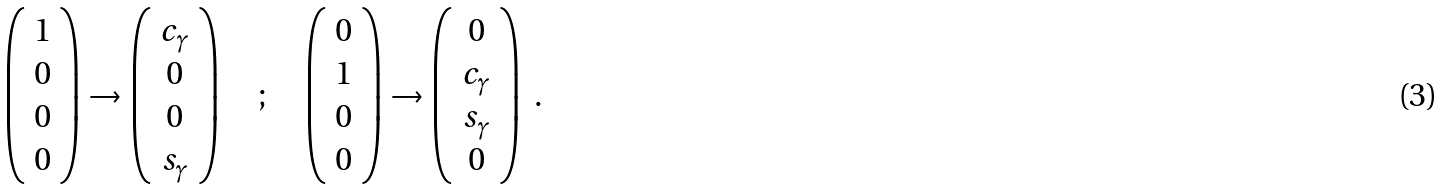<formula> <loc_0><loc_0><loc_500><loc_500>\left ( \begin{array} { c } 1 \\ 0 \\ 0 \\ 0 \end{array} \right ) \rightarrow \left ( \begin{array} { c } c _ { \gamma } \\ 0 \\ 0 \\ s _ { \gamma } \end{array} \right ) \quad ; \quad \left ( \begin{array} { c } 0 \\ 1 \\ 0 \\ 0 \end{array} \right ) \rightarrow \left ( \begin{array} { c } 0 \\ c _ { \gamma } \\ s _ { \gamma } \\ 0 \end{array} \right ) \ .</formula> 